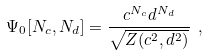<formula> <loc_0><loc_0><loc_500><loc_500>\Psi _ { 0 } [ N _ { c } , N _ { d } ] = \frac { c ^ { N _ { c } } d ^ { N _ { d } } } { \sqrt { Z ( c ^ { 2 } , d ^ { 2 } ) } } \ ,</formula> 